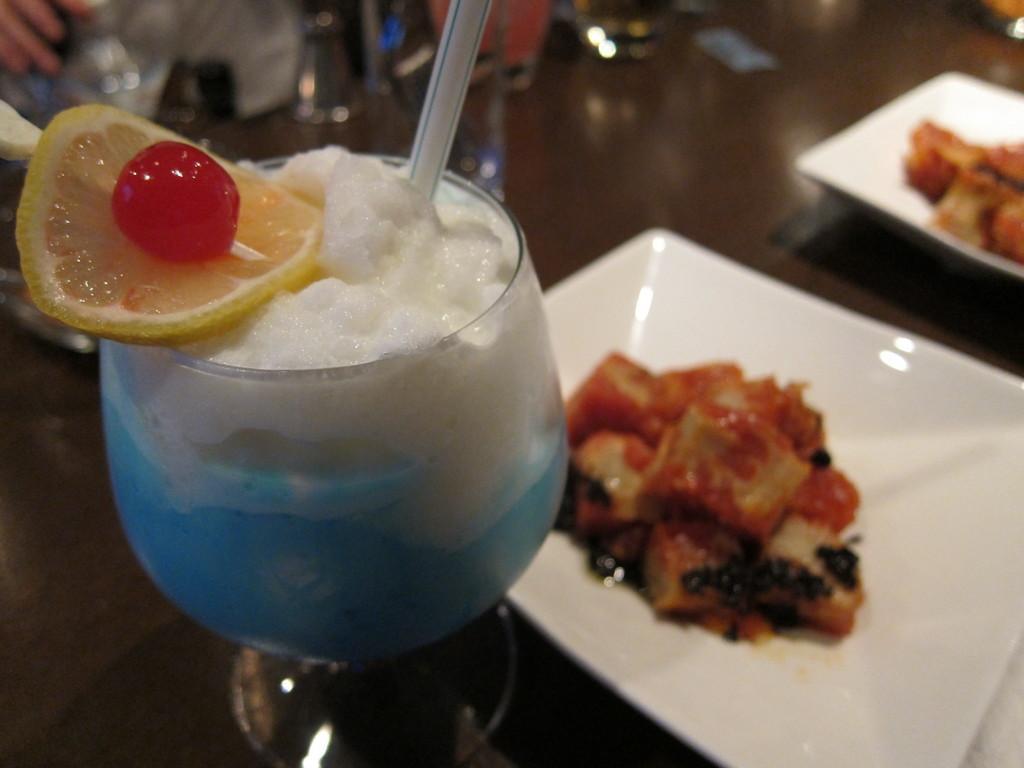Can you describe this image briefly? In this image we can see the food item in two different white plates which is on the wooden table. We can also see a glass with a straw and on the top of the glass we can see a fruit and also a cherry. 